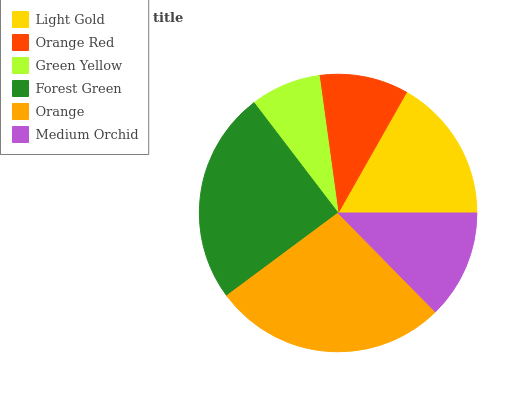Is Green Yellow the minimum?
Answer yes or no. Yes. Is Orange the maximum?
Answer yes or no. Yes. Is Orange Red the minimum?
Answer yes or no. No. Is Orange Red the maximum?
Answer yes or no. No. Is Light Gold greater than Orange Red?
Answer yes or no. Yes. Is Orange Red less than Light Gold?
Answer yes or no. Yes. Is Orange Red greater than Light Gold?
Answer yes or no. No. Is Light Gold less than Orange Red?
Answer yes or no. No. Is Light Gold the high median?
Answer yes or no. Yes. Is Medium Orchid the low median?
Answer yes or no. Yes. Is Green Yellow the high median?
Answer yes or no. No. Is Forest Green the low median?
Answer yes or no. No. 